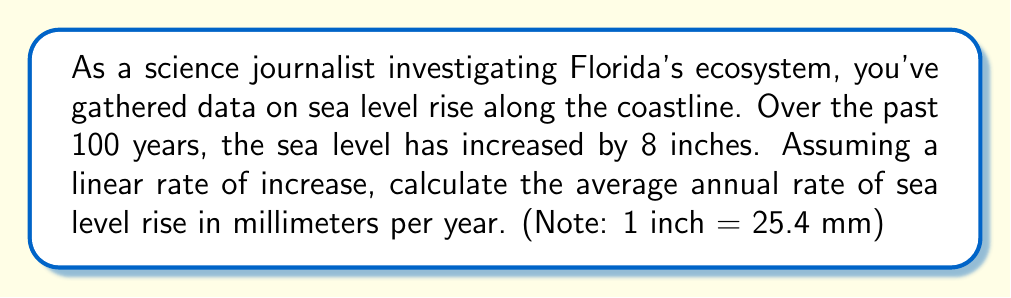Show me your answer to this math problem. Let's approach this step-by-step:

1) First, we need to convert the sea level rise from inches to millimeters:
   $$ 8 \text{ inches} \times 25.4 \frac{\text{mm}}{\text{inch}} = 203.2 \text{ mm} $$

2) Now we have the total sea level rise over 100 years in millimeters:
   $$ \text{Total rise} = 203.2 \text{ mm} $$
   $$ \text{Time period} = 100 \text{ years} $$

3) To find the average annual rate, we divide the total rise by the number of years:
   $$ \text{Annual rate} = \frac{\text{Total rise}}{\text{Time period}} $$
   $$ = \frac{203.2 \text{ mm}}{100 \text{ years}} $$
   $$ = 2.032 \text{ mm/year} $$

4) Rounding to two decimal places for practical reporting:
   $$ \text{Annual rate} \approx 2.03 \text{ mm/year} $$

Therefore, the average annual rate of sea level rise along Florida's coastline is approximately 2.03 mm/year.
Answer: 2.03 mm/year 